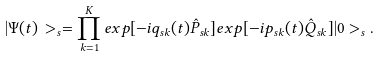<formula> <loc_0><loc_0><loc_500><loc_500>| \Psi ( t ) \, > _ { s } = \prod _ { k = 1 } ^ { K } e x p [ - i q _ { s k } ( t ) \hat { P } _ { s k } ] e x p [ - i p _ { s k } ( t ) \hat { Q } _ { s k } ] | 0 > _ { s } .</formula> 